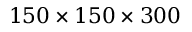<formula> <loc_0><loc_0><loc_500><loc_500>1 5 0 \times 1 5 0 \times 3 0 0</formula> 